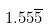Convert formula to latex. <formula><loc_0><loc_0><loc_500><loc_500>1 . 5 5 \overline { 5 }</formula> 